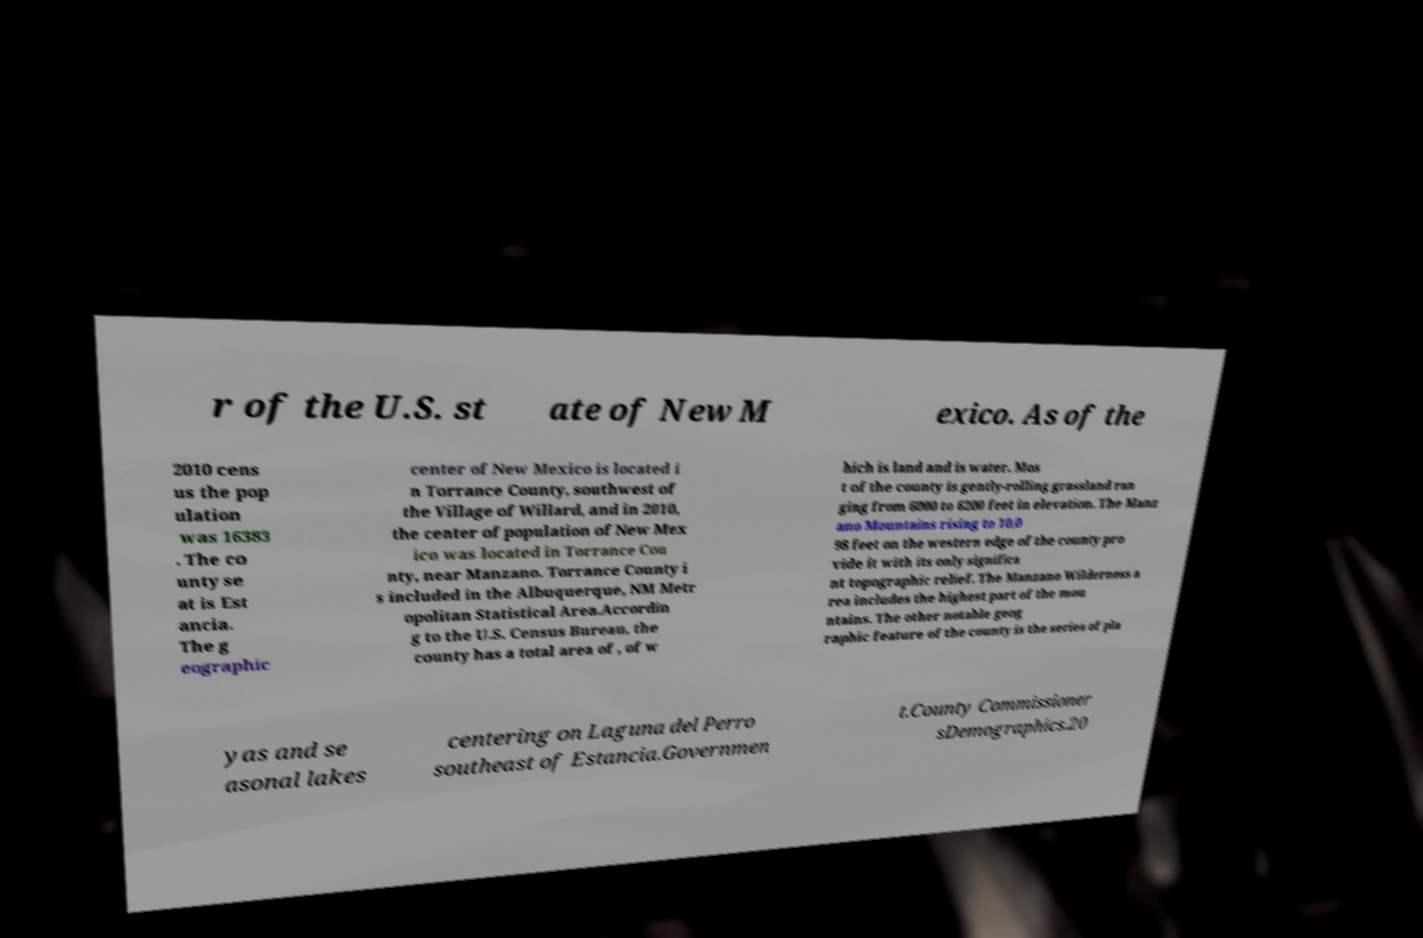Could you extract and type out the text from this image? r of the U.S. st ate of New M exico. As of the 2010 cens us the pop ulation was 16383 . The co unty se at is Est ancia. The g eographic center of New Mexico is located i n Torrance County, southwest of the Village of Willard, and in 2010, the center of population of New Mex ico was located in Torrance Cou nty, near Manzano. Torrance County i s included in the Albuquerque, NM Metr opolitan Statistical Area.Accordin g to the U.S. Census Bureau, the county has a total area of , of w hich is land and is water. Mos t of the county is gently-rolling grassland ran ging from 6000 to 6200 feet in elevation. The Manz ano Mountains rising to 10,0 98 feet on the western edge of the county pro vide it with its only significa nt topographic relief. The Manzano Wilderness a rea includes the highest part of the mou ntains. The other notable geog raphic feature of the county is the series of pla yas and se asonal lakes centering on Laguna del Perro southeast of Estancia.Governmen t.County Commissioner sDemographics.20 